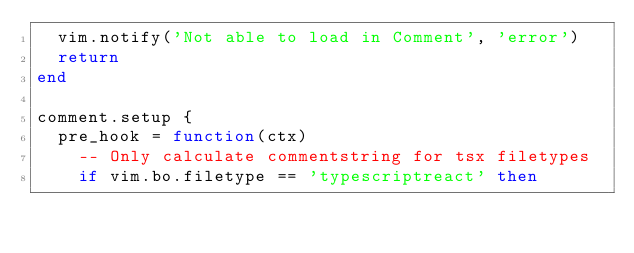<code> <loc_0><loc_0><loc_500><loc_500><_Lua_>  vim.notify('Not able to load in Comment', 'error')
  return
end

comment.setup {
  pre_hook = function(ctx)
    -- Only calculate commentstring for tsx filetypes
    if vim.bo.filetype == 'typescriptreact' then</code> 